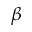Convert formula to latex. <formula><loc_0><loc_0><loc_500><loc_500>\beta</formula> 